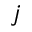Convert formula to latex. <formula><loc_0><loc_0><loc_500><loc_500>j</formula> 